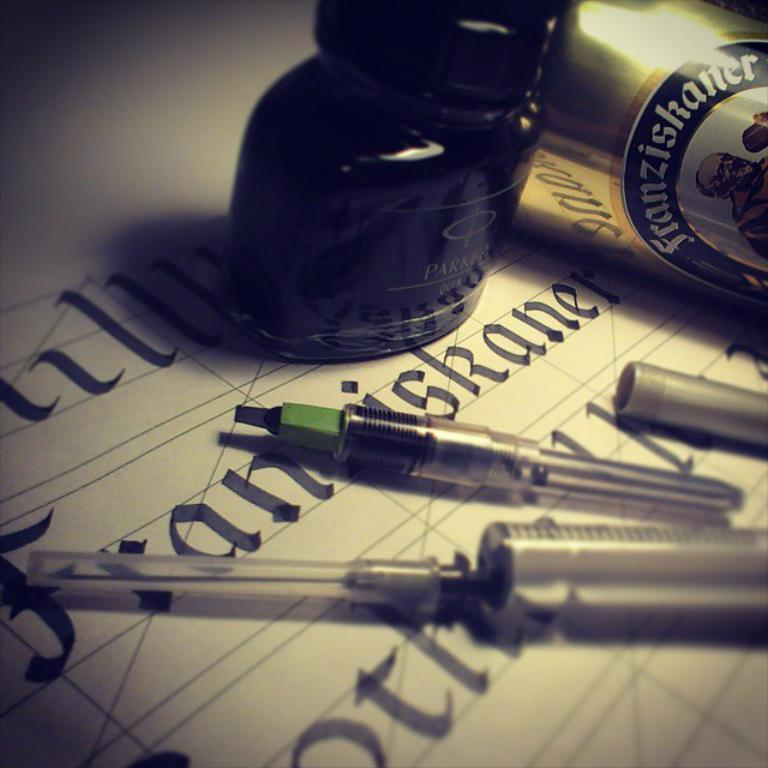What is written on the surface in the image? There is text on the surface in the image. What medical instrument is present in the image? There is a syringe in the image. What writing instrument is visible in the image? There is a pen in the image. What container is present in the image? There is a bottle in the image. What other object with text can be seen in the image? There is another object with text in the image. How many ants are crawling on the syringe in the image? There are no ants present in the image; it only features a syringe, a pen, a bottle, and text on surfaces. What type of metal is the blade made of in the image? There is no blade present in the image. 